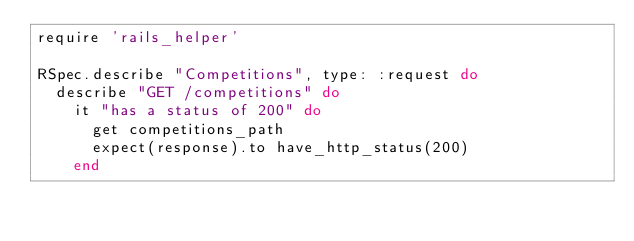Convert code to text. <code><loc_0><loc_0><loc_500><loc_500><_Ruby_>require 'rails_helper'

RSpec.describe "Competitions", type: :request do
  describe "GET /competitions" do
    it "has a status of 200" do
      get competitions_path
      expect(response).to have_http_status(200)
    end</code> 